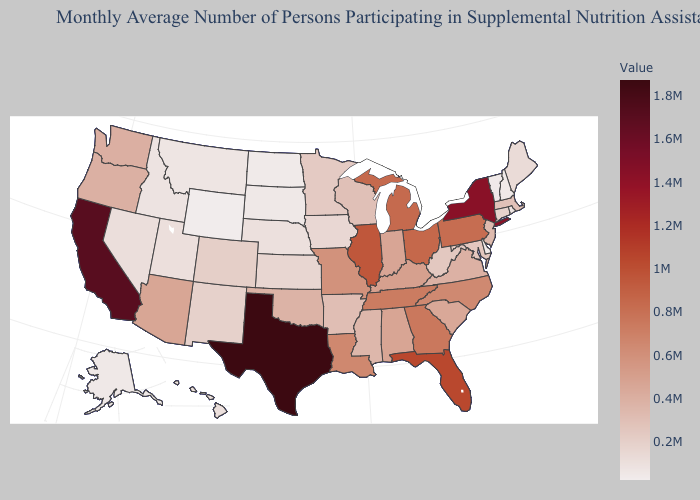Does North Dakota have a higher value than California?
Give a very brief answer. No. Among the states that border Vermont , which have the lowest value?
Concise answer only. New Hampshire. Does Illinois have the highest value in the MidWest?
Quick response, please. Yes. Among the states that border Oklahoma , does Kansas have the lowest value?
Answer briefly. Yes. Does Texas have the highest value in the South?
Write a very short answer. Yes. 